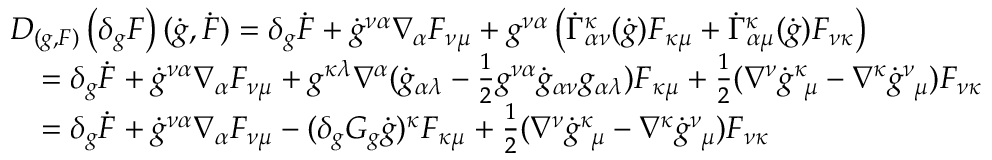<formula> <loc_0><loc_0><loc_500><loc_500>\begin{array} { r l } & { D _ { ( g , F ) } \left ( \delta _ { g } F \right ) ( \dot { g } , \dot { F } ) = \delta _ { g } \dot { F } + \dot { g } ^ { \nu \alpha } \nabla _ { \alpha } F _ { \nu \mu } + g ^ { \nu \alpha } \left ( \dot { \Gamma } _ { \alpha \nu } ^ { \kappa } ( \dot { g } ) F _ { \kappa \mu } + \dot { \Gamma } _ { \alpha \mu } ^ { \kappa } ( \dot { g } ) F _ { \nu \kappa } \right ) } \\ & { \quad = \delta _ { g } \dot { F } + \dot { g } ^ { \nu \alpha } \nabla _ { \alpha } F _ { \nu \mu } + g ^ { \kappa \lambda } \nabla ^ { \alpha } ( \dot { g } _ { \alpha \lambda } - \frac { 1 } { 2 } g ^ { \nu \alpha } \dot { g } _ { \alpha \nu } g _ { \alpha \lambda } ) F _ { \kappa \mu } + \frac { 1 } { 2 } ( \nabla ^ { \nu } \dot { g } _ { \mu } ^ { \kappa } - \nabla ^ { \kappa } \dot { g } _ { \mu } ^ { \nu } ) F _ { \nu \kappa } } \\ & { \quad = \delta _ { g } \dot { F } + \dot { g } ^ { \nu \alpha } \nabla _ { \alpha } F _ { \nu \mu } - ( \delta _ { g } G _ { g } \dot { g } ) ^ { \kappa } F _ { \kappa \mu } + \frac { 1 } { 2 } ( \nabla ^ { \nu } \dot { g } _ { \mu } ^ { \kappa } - \nabla ^ { \kappa } \dot { g } _ { \mu } ^ { \nu } ) F _ { \nu \kappa } } \end{array}</formula> 